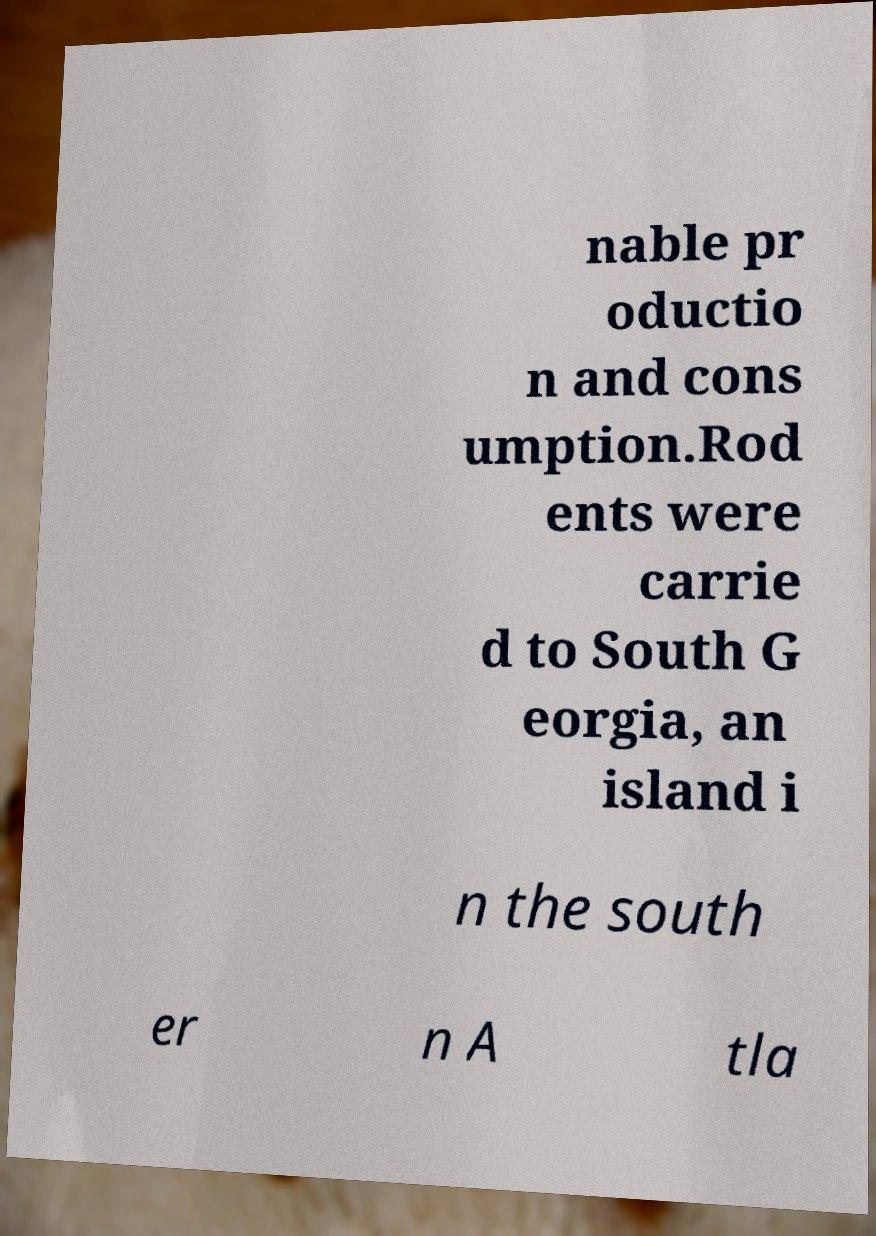There's text embedded in this image that I need extracted. Can you transcribe it verbatim? nable pr oductio n and cons umption.Rod ents were carrie d to South G eorgia, an island i n the south er n A tla 